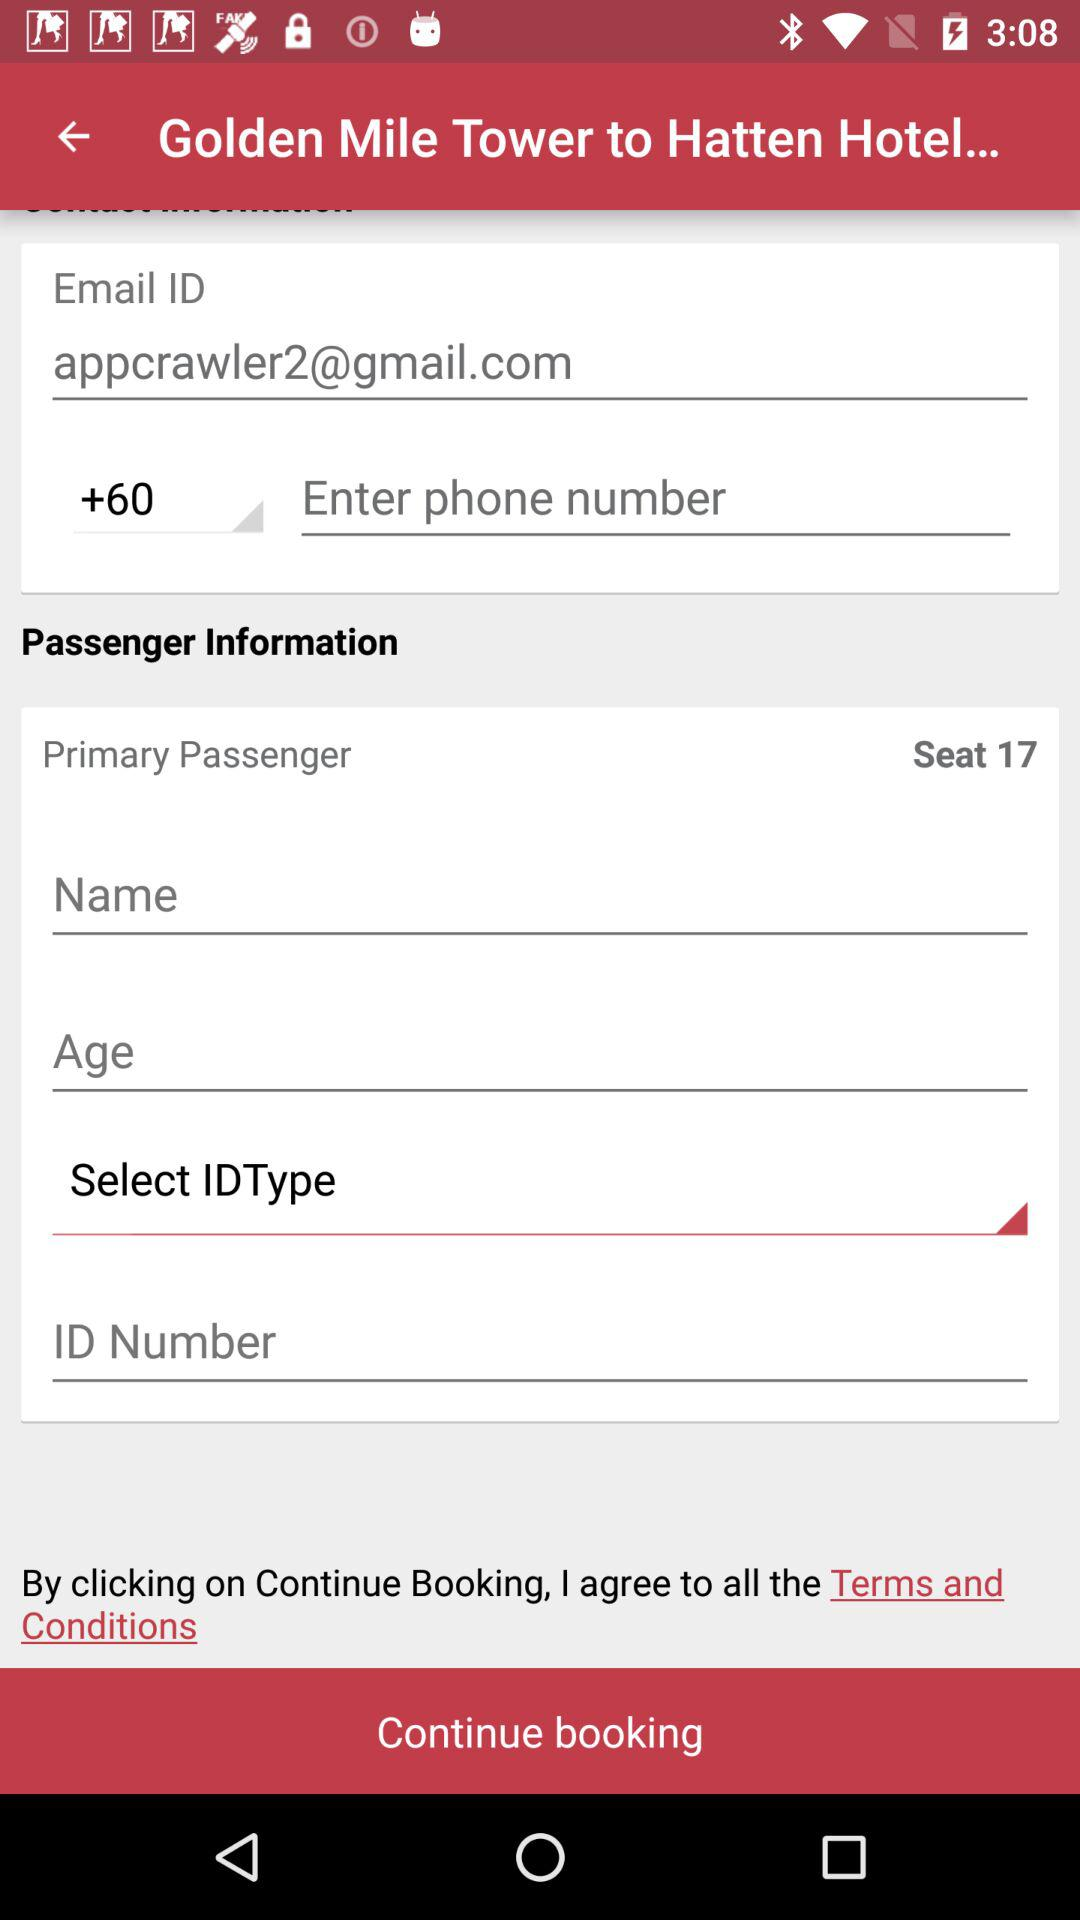What Gmail address is used? The Gmail address is appcrawler2@gmail.com. 